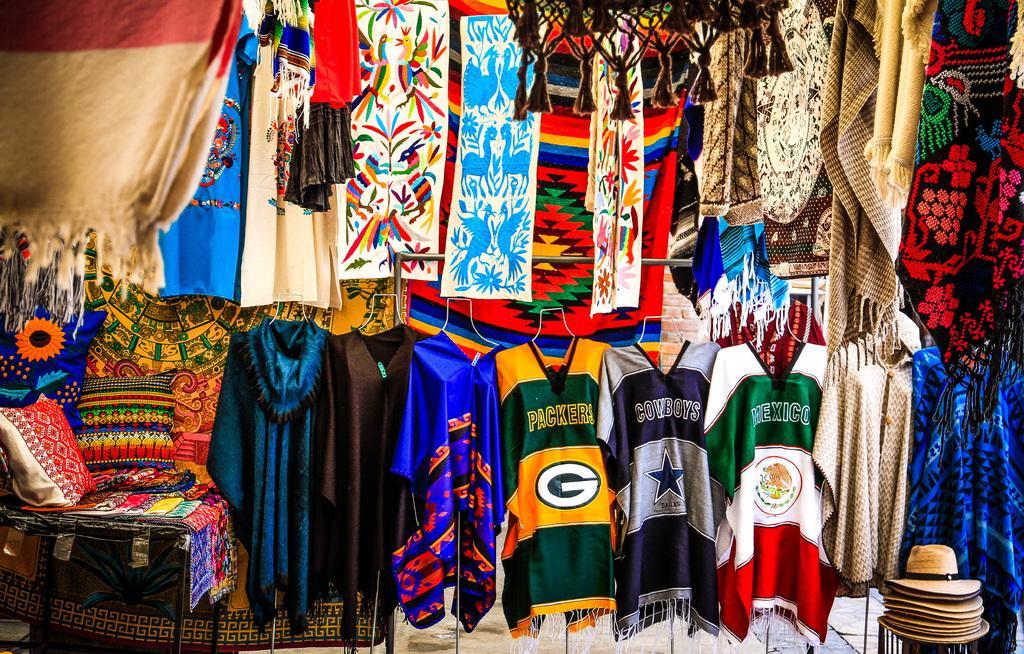How would you summarize this image in a sentence or two? This picture is clicked in the textile shop. At the bottom of the picture, we see many T-shirts or jackets which are in brown, blue, yellow, grey, green and white color are hanged to the hangers. Beside that, we see pillows, bed sheets and mats. At the top of the picture, we see clothes in different colors. In the right bottom of the picture, we see the hats. 